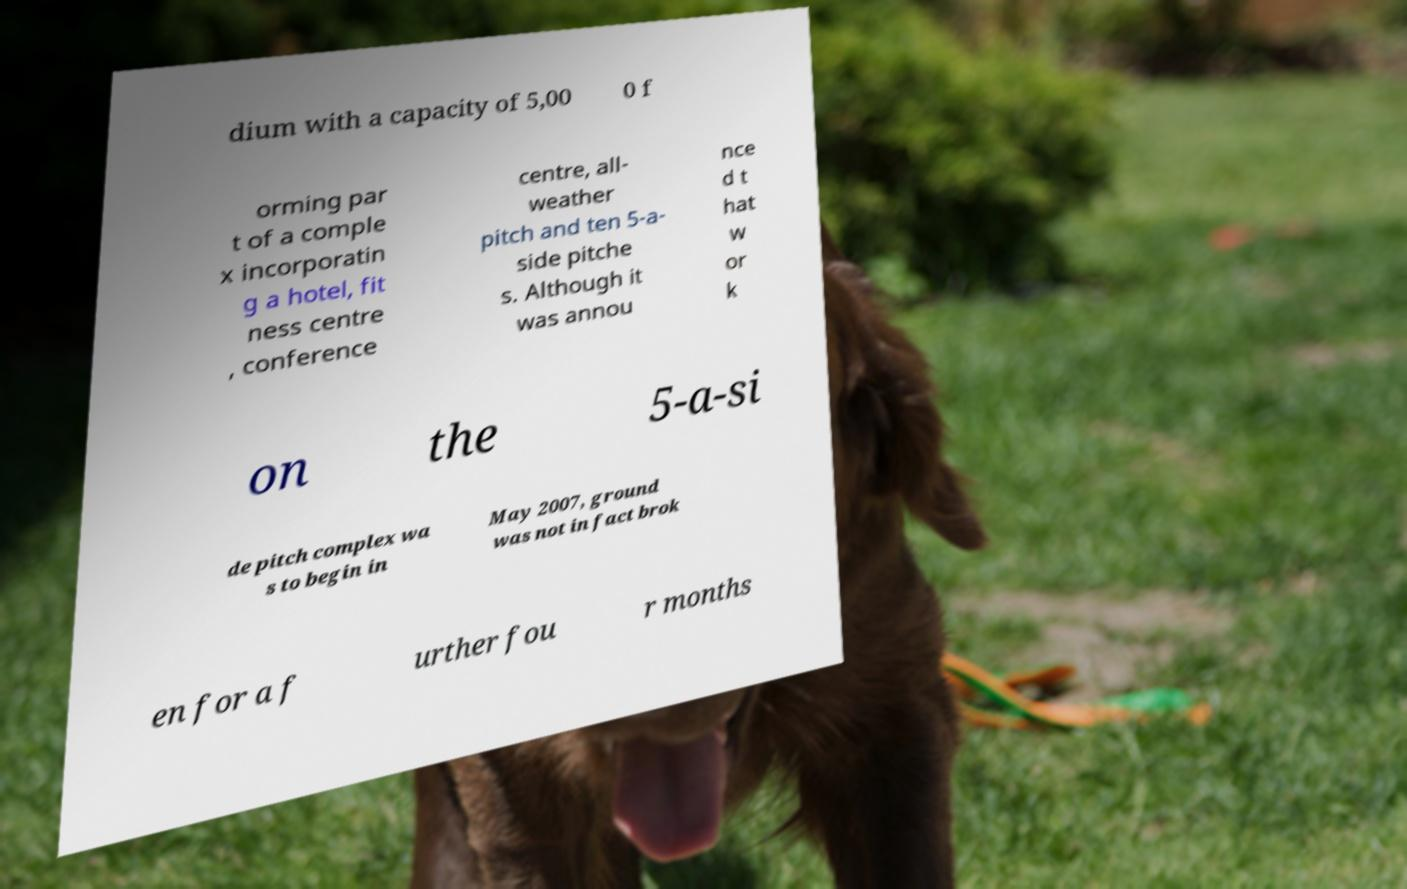Could you assist in decoding the text presented in this image and type it out clearly? dium with a capacity of 5,00 0 f orming par t of a comple x incorporatin g a hotel, fit ness centre , conference centre, all- weather pitch and ten 5-a- side pitche s. Although it was annou nce d t hat w or k on the 5-a-si de pitch complex wa s to begin in May 2007, ground was not in fact brok en for a f urther fou r months 